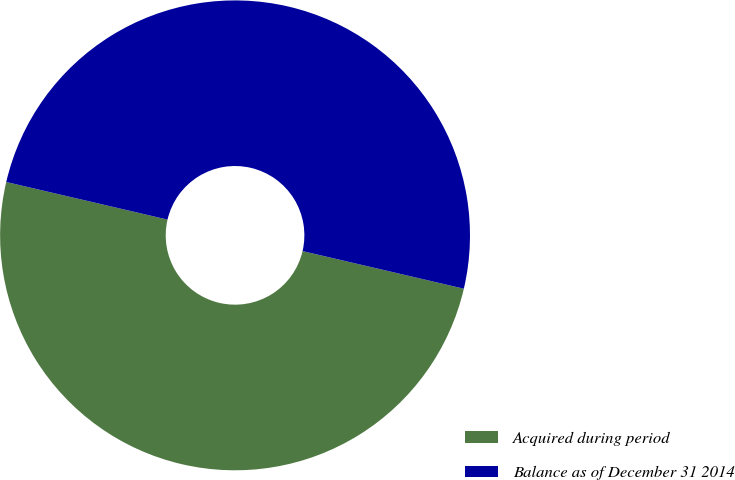<chart> <loc_0><loc_0><loc_500><loc_500><pie_chart><fcel>Acquired during period<fcel>Balance as of December 31 2014<nl><fcel>50.0%<fcel>50.0%<nl></chart> 